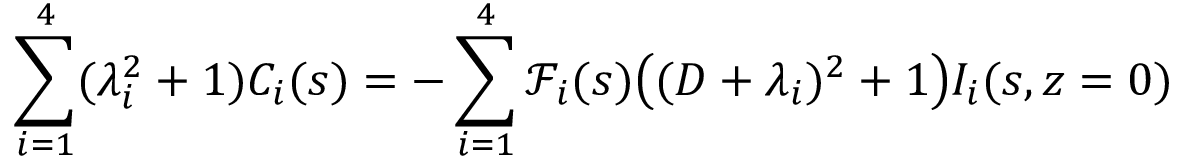<formula> <loc_0><loc_0><loc_500><loc_500>\sum _ { i = 1 } ^ { 4 } ( \lambda _ { i } ^ { 2 } + 1 ) C _ { i } ( s ) = - \sum _ { i = 1 } ^ { 4 } \ m a t h s c r { F } _ { i } ( s ) \left ( ( D + \lambda _ { i } ) ^ { 2 } + 1 \right ) I _ { i } ( s , z = 0 )</formula> 